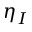Convert formula to latex. <formula><loc_0><loc_0><loc_500><loc_500>\eta _ { I }</formula> 